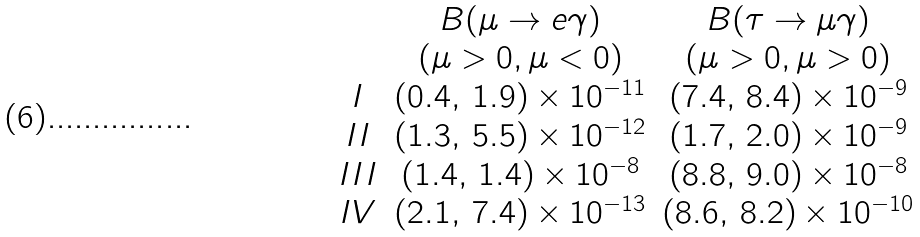<formula> <loc_0><loc_0><loc_500><loc_500>\begin{array} { c c c } & B ( \mu \rightarrow e \gamma ) & B ( \tau \rightarrow \mu \gamma ) \\ & ( \mu > 0 , \mu < 0 ) & ( \mu > 0 , \mu > 0 ) \\ I & ( 0 . 4 , \, 1 . 9 ) \times 1 0 ^ { - 1 1 } & ( 7 . 4 , \, 8 . 4 ) \times 1 0 ^ { - 9 } \\ I I & ( 1 . 3 , \, 5 . 5 ) \times 1 0 ^ { - 1 2 } & ( 1 . 7 , \, 2 . 0 ) \times 1 0 ^ { - 9 } \\ I I I & ( 1 . 4 , \, 1 . 4 ) \times 1 0 ^ { - 8 } & ( 8 . 8 , \, 9 . 0 ) \times 1 0 ^ { - 8 } \\ I V & ( 2 . 1 , \, 7 . 4 ) \times 1 0 ^ { - 1 3 } & ( 8 . 6 , \, 8 . 2 ) \times 1 0 ^ { - 1 0 } \end{array}</formula> 